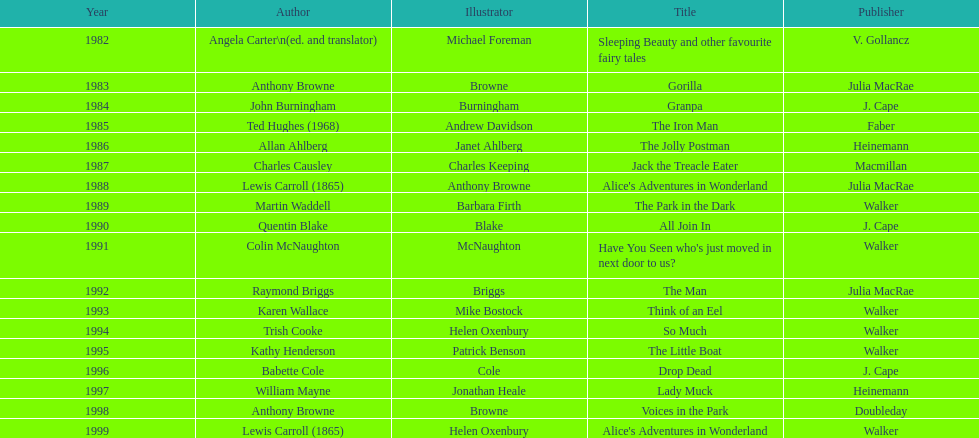How many titles had the same writer listed as the illustrator? 7. 